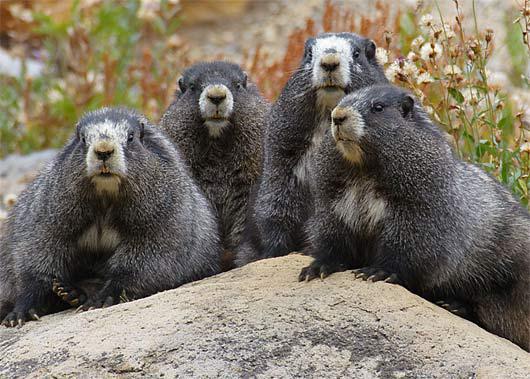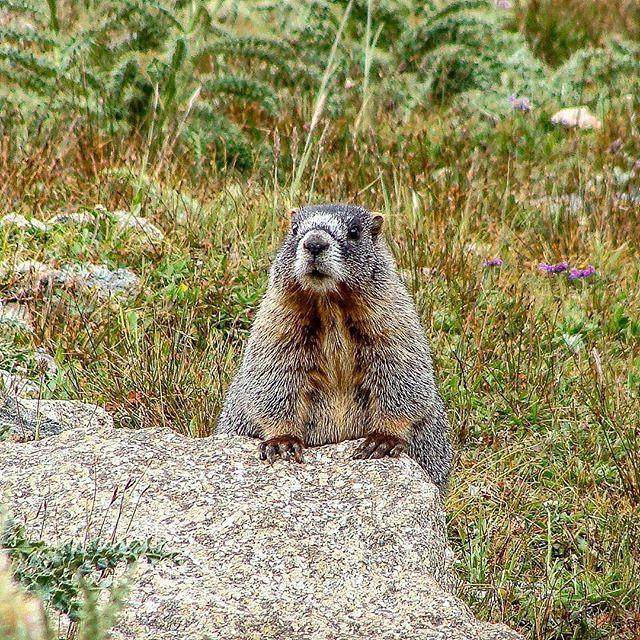The first image is the image on the left, the second image is the image on the right. Considering the images on both sides, is "At least two animals are very close to each other." valid? Answer yes or no. Yes. 